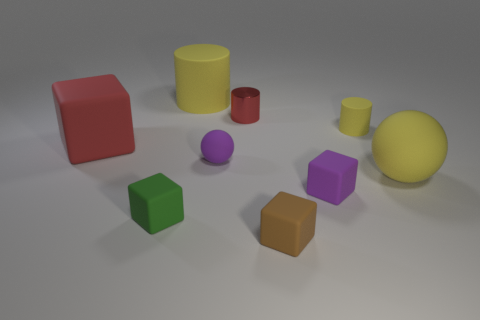Which shape in the image has the largest volume? The yellow cylinder appears to have the largest volume among the shapes present in the image, given its dimensions compared to the others. 